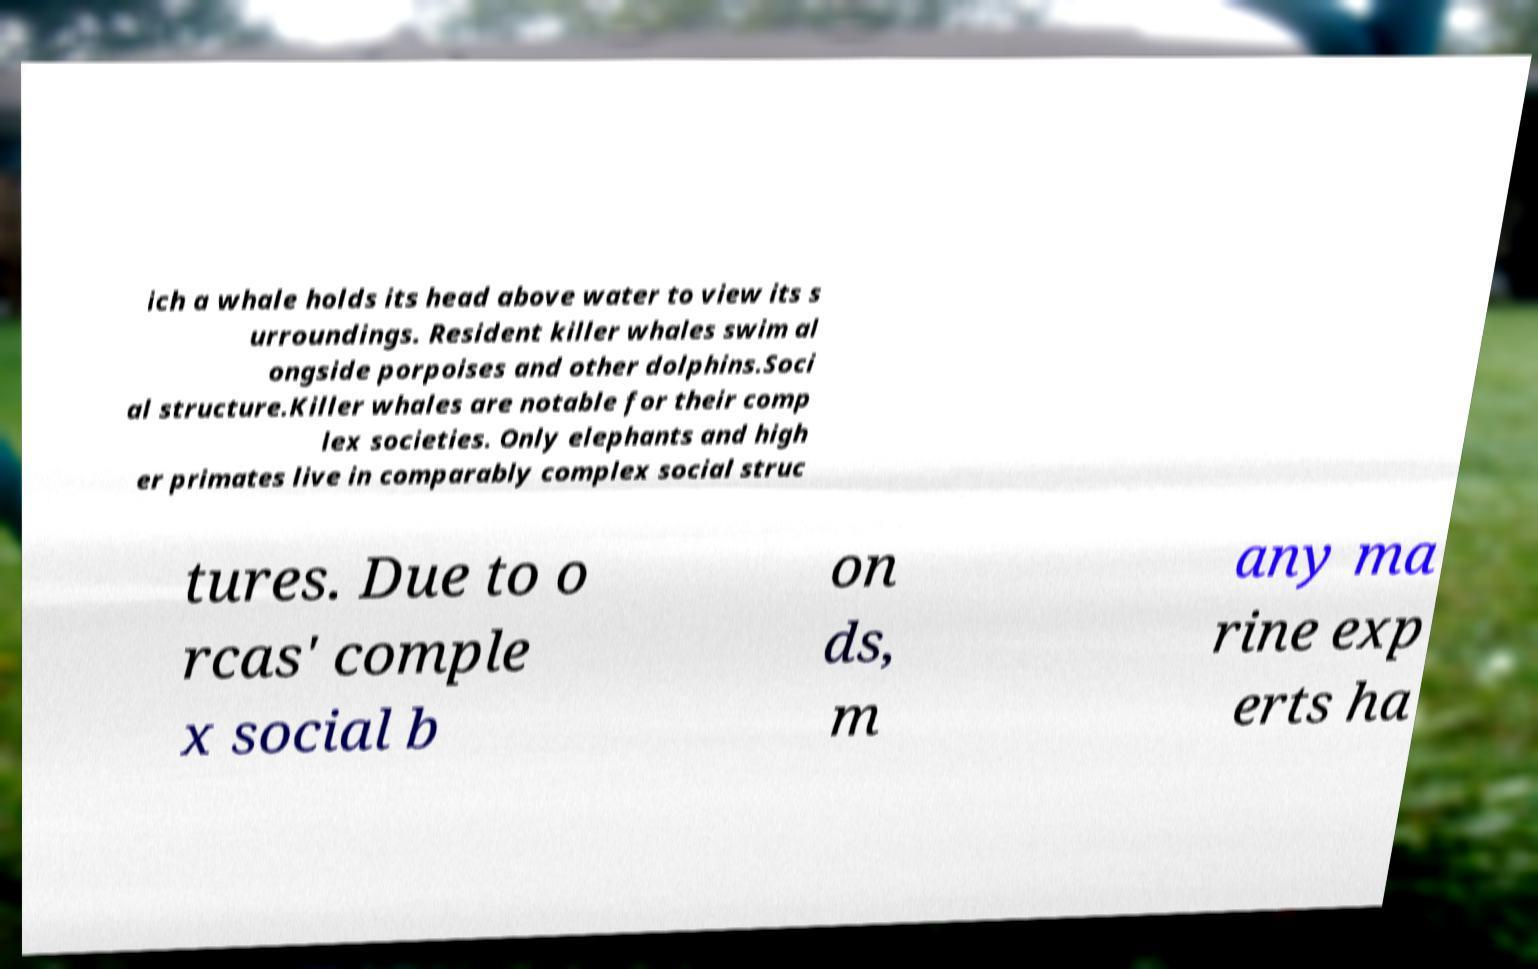Can you read and provide the text displayed in the image?This photo seems to have some interesting text. Can you extract and type it out for me? ich a whale holds its head above water to view its s urroundings. Resident killer whales swim al ongside porpoises and other dolphins.Soci al structure.Killer whales are notable for their comp lex societies. Only elephants and high er primates live in comparably complex social struc tures. Due to o rcas' comple x social b on ds, m any ma rine exp erts ha 